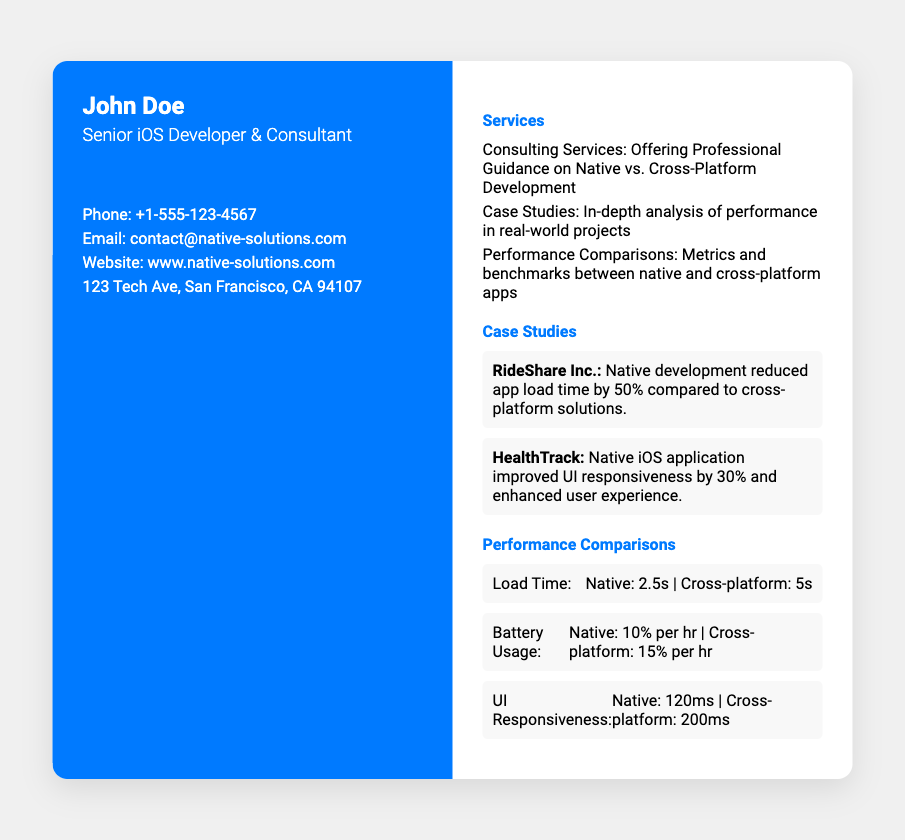What is the name of the consultant? The name of the consultant is John Doe, as stated in the left side of the document.
Answer: John Doe What is the email address provided? The email address for contact is mentioned in the contact info section.
Answer: contact@native-solutions.com What service does John Doe offer? The document clearly states he offers consulting services on native vs. cross-platform development.
Answer: Consulting Services What is the load time for native apps? The performance comparisons section lists the load time for native apps specifically.
Answer: 2.5s Which company is associated with a 50% reduction in app load time? The case studies section highlights RideShare Inc. for its performance improvement.
Answer: RideShare Inc What is the address listed on the business card? The address is provided in the contact info section of the left side.
Answer: 123 Tech Ave, San Francisco, CA 94107 How much battery does the cross-platform app use per hour? The performance comparisons section includes the battery usage for cross-platform apps.
Answer: 15% per hr How much did UI responsiveness improve for HealthTrack? The case studies section indicates that HealthTrack had a specific improvement in UI responsiveness.
Answer: 30% What platform is John Doe advocating for? The document clearly indicates his advocacy preference regarding development platforms.
Answer: Native 